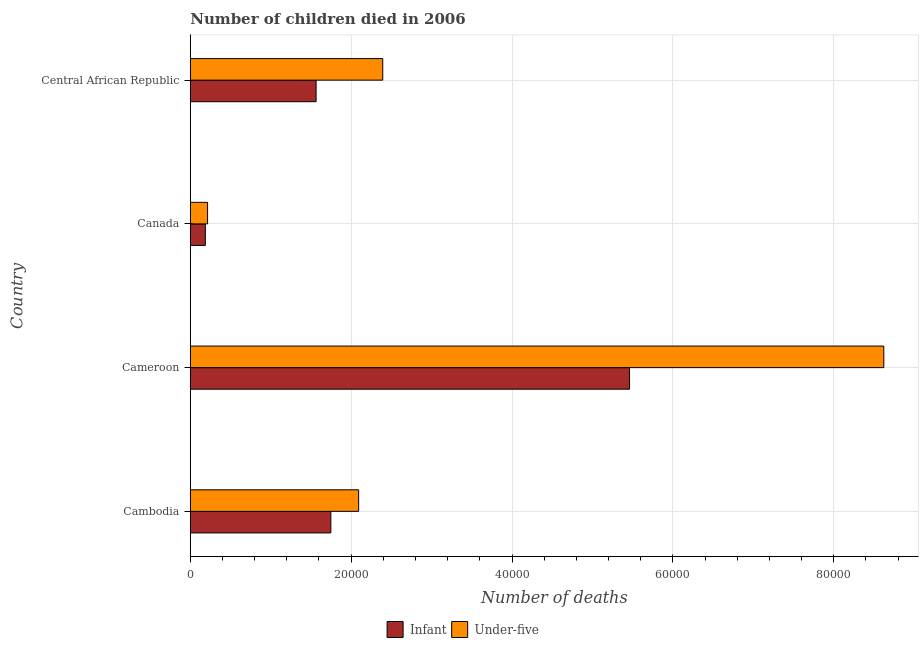Are the number of bars per tick equal to the number of legend labels?
Provide a short and direct response. Yes. How many bars are there on the 4th tick from the top?
Offer a very short reply. 2. How many bars are there on the 3rd tick from the bottom?
Give a very brief answer. 2. What is the label of the 1st group of bars from the top?
Provide a short and direct response. Central African Republic. What is the number of under-five deaths in Canada?
Provide a succinct answer. 2149. Across all countries, what is the maximum number of infant deaths?
Provide a succinct answer. 5.46e+04. Across all countries, what is the minimum number of under-five deaths?
Provide a short and direct response. 2149. In which country was the number of infant deaths maximum?
Make the answer very short. Cameroon. What is the total number of infant deaths in the graph?
Give a very brief answer. 8.96e+04. What is the difference between the number of infant deaths in Cambodia and that in Central African Republic?
Your response must be concise. 1833. What is the difference between the number of under-five deaths in Canada and the number of infant deaths in Cambodia?
Ensure brevity in your answer.  -1.53e+04. What is the average number of under-five deaths per country?
Your response must be concise. 3.33e+04. What is the difference between the number of under-five deaths and number of infant deaths in Cameroon?
Ensure brevity in your answer.  3.16e+04. What is the ratio of the number of under-five deaths in Cambodia to that in Cameroon?
Your answer should be compact. 0.24. Is the number of under-five deaths in Cambodia less than that in Cameroon?
Offer a terse response. Yes. Is the difference between the number of infant deaths in Cambodia and Cameroon greater than the difference between the number of under-five deaths in Cambodia and Cameroon?
Provide a short and direct response. Yes. What is the difference between the highest and the second highest number of infant deaths?
Offer a very short reply. 3.71e+04. What is the difference between the highest and the lowest number of under-five deaths?
Provide a succinct answer. 8.41e+04. In how many countries, is the number of under-five deaths greater than the average number of under-five deaths taken over all countries?
Give a very brief answer. 1. What does the 1st bar from the top in Cambodia represents?
Keep it short and to the point. Under-five. What does the 2nd bar from the bottom in Cameroon represents?
Offer a terse response. Under-five. What is the difference between two consecutive major ticks on the X-axis?
Provide a short and direct response. 2.00e+04. Are the values on the major ticks of X-axis written in scientific E-notation?
Make the answer very short. No. Does the graph contain any zero values?
Your answer should be compact. No. Does the graph contain grids?
Ensure brevity in your answer.  Yes. How are the legend labels stacked?
Provide a succinct answer. Horizontal. What is the title of the graph?
Provide a succinct answer. Number of children died in 2006. Does "Private credit bureau" appear as one of the legend labels in the graph?
Your response must be concise. No. What is the label or title of the X-axis?
Your response must be concise. Number of deaths. What is the Number of deaths in Infant in Cambodia?
Provide a succinct answer. 1.75e+04. What is the Number of deaths of Under-five in Cambodia?
Your response must be concise. 2.09e+04. What is the Number of deaths in Infant in Cameroon?
Your answer should be very brief. 5.46e+04. What is the Number of deaths of Under-five in Cameroon?
Offer a very short reply. 8.62e+04. What is the Number of deaths of Infant in Canada?
Your answer should be very brief. 1871. What is the Number of deaths in Under-five in Canada?
Offer a terse response. 2149. What is the Number of deaths of Infant in Central African Republic?
Provide a short and direct response. 1.56e+04. What is the Number of deaths of Under-five in Central African Republic?
Give a very brief answer. 2.39e+04. Across all countries, what is the maximum Number of deaths of Infant?
Keep it short and to the point. 5.46e+04. Across all countries, what is the maximum Number of deaths in Under-five?
Ensure brevity in your answer.  8.62e+04. Across all countries, what is the minimum Number of deaths of Infant?
Provide a short and direct response. 1871. Across all countries, what is the minimum Number of deaths in Under-five?
Ensure brevity in your answer.  2149. What is the total Number of deaths of Infant in the graph?
Offer a very short reply. 8.96e+04. What is the total Number of deaths in Under-five in the graph?
Provide a short and direct response. 1.33e+05. What is the difference between the Number of deaths in Infant in Cambodia and that in Cameroon?
Offer a very short reply. -3.71e+04. What is the difference between the Number of deaths of Under-five in Cambodia and that in Cameroon?
Your response must be concise. -6.53e+04. What is the difference between the Number of deaths of Infant in Cambodia and that in Canada?
Provide a succinct answer. 1.56e+04. What is the difference between the Number of deaths in Under-five in Cambodia and that in Canada?
Your answer should be compact. 1.88e+04. What is the difference between the Number of deaths of Infant in Cambodia and that in Central African Republic?
Your response must be concise. 1833. What is the difference between the Number of deaths of Under-five in Cambodia and that in Central African Republic?
Your answer should be very brief. -2997. What is the difference between the Number of deaths of Infant in Cameroon and that in Canada?
Your answer should be very brief. 5.27e+04. What is the difference between the Number of deaths in Under-five in Cameroon and that in Canada?
Your answer should be very brief. 8.41e+04. What is the difference between the Number of deaths of Infant in Cameroon and that in Central African Republic?
Your response must be concise. 3.90e+04. What is the difference between the Number of deaths in Under-five in Cameroon and that in Central African Republic?
Offer a very short reply. 6.23e+04. What is the difference between the Number of deaths in Infant in Canada and that in Central African Republic?
Make the answer very short. -1.38e+04. What is the difference between the Number of deaths in Under-five in Canada and that in Central African Republic?
Give a very brief answer. -2.18e+04. What is the difference between the Number of deaths of Infant in Cambodia and the Number of deaths of Under-five in Cameroon?
Ensure brevity in your answer.  -6.87e+04. What is the difference between the Number of deaths in Infant in Cambodia and the Number of deaths in Under-five in Canada?
Provide a short and direct response. 1.53e+04. What is the difference between the Number of deaths of Infant in Cambodia and the Number of deaths of Under-five in Central African Republic?
Give a very brief answer. -6454. What is the difference between the Number of deaths in Infant in Cameroon and the Number of deaths in Under-five in Canada?
Give a very brief answer. 5.25e+04. What is the difference between the Number of deaths in Infant in Cameroon and the Number of deaths in Under-five in Central African Republic?
Your response must be concise. 3.07e+04. What is the difference between the Number of deaths in Infant in Canada and the Number of deaths in Under-five in Central African Republic?
Provide a short and direct response. -2.21e+04. What is the average Number of deaths of Infant per country?
Give a very brief answer. 2.24e+04. What is the average Number of deaths of Under-five per country?
Ensure brevity in your answer.  3.33e+04. What is the difference between the Number of deaths of Infant and Number of deaths of Under-five in Cambodia?
Offer a very short reply. -3457. What is the difference between the Number of deaths of Infant and Number of deaths of Under-five in Cameroon?
Your response must be concise. -3.16e+04. What is the difference between the Number of deaths of Infant and Number of deaths of Under-five in Canada?
Give a very brief answer. -278. What is the difference between the Number of deaths of Infant and Number of deaths of Under-five in Central African Republic?
Give a very brief answer. -8287. What is the ratio of the Number of deaths of Infant in Cambodia to that in Cameroon?
Offer a very short reply. 0.32. What is the ratio of the Number of deaths of Under-five in Cambodia to that in Cameroon?
Provide a short and direct response. 0.24. What is the ratio of the Number of deaths of Infant in Cambodia to that in Canada?
Ensure brevity in your answer.  9.34. What is the ratio of the Number of deaths in Under-five in Cambodia to that in Canada?
Your answer should be compact. 9.74. What is the ratio of the Number of deaths of Infant in Cambodia to that in Central African Republic?
Keep it short and to the point. 1.12. What is the ratio of the Number of deaths of Under-five in Cambodia to that in Central African Republic?
Keep it short and to the point. 0.87. What is the ratio of the Number of deaths of Infant in Cameroon to that in Canada?
Your response must be concise. 29.19. What is the ratio of the Number of deaths of Under-five in Cameroon to that in Canada?
Give a very brief answer. 40.12. What is the ratio of the Number of deaths in Infant in Cameroon to that in Central African Republic?
Offer a terse response. 3.49. What is the ratio of the Number of deaths in Under-five in Cameroon to that in Central African Republic?
Your answer should be very brief. 3.6. What is the ratio of the Number of deaths in Infant in Canada to that in Central African Republic?
Provide a short and direct response. 0.12. What is the ratio of the Number of deaths in Under-five in Canada to that in Central African Republic?
Give a very brief answer. 0.09. What is the difference between the highest and the second highest Number of deaths of Infant?
Give a very brief answer. 3.71e+04. What is the difference between the highest and the second highest Number of deaths of Under-five?
Ensure brevity in your answer.  6.23e+04. What is the difference between the highest and the lowest Number of deaths of Infant?
Offer a very short reply. 5.27e+04. What is the difference between the highest and the lowest Number of deaths in Under-five?
Offer a terse response. 8.41e+04. 